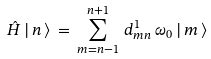<formula> <loc_0><loc_0><loc_500><loc_500>\hat { H } \, | \, n \, \rangle \, = \, \sum _ { m = n - 1 } ^ { n + 1 } \, d ^ { 1 } _ { m n } \, \omega _ { 0 } \, | \, m \, \rangle</formula> 